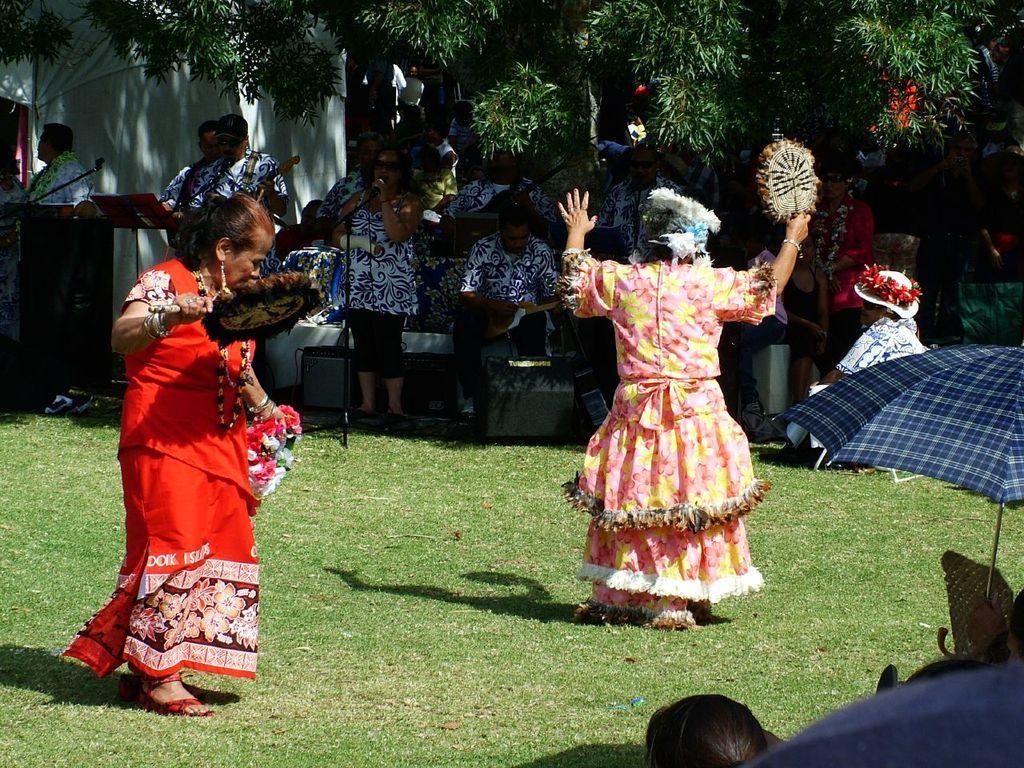Can you describe this image briefly? The woman in the red dress and the woman in the pink dress are dancing. Behind them, we see people playing musical instrument. The woman in white dress is holding a microphone in her hand and she is singing the song on the microphone. There are trees and a white building in the background. At the bottom of the picture, we see an umbrella which is blue in color. 